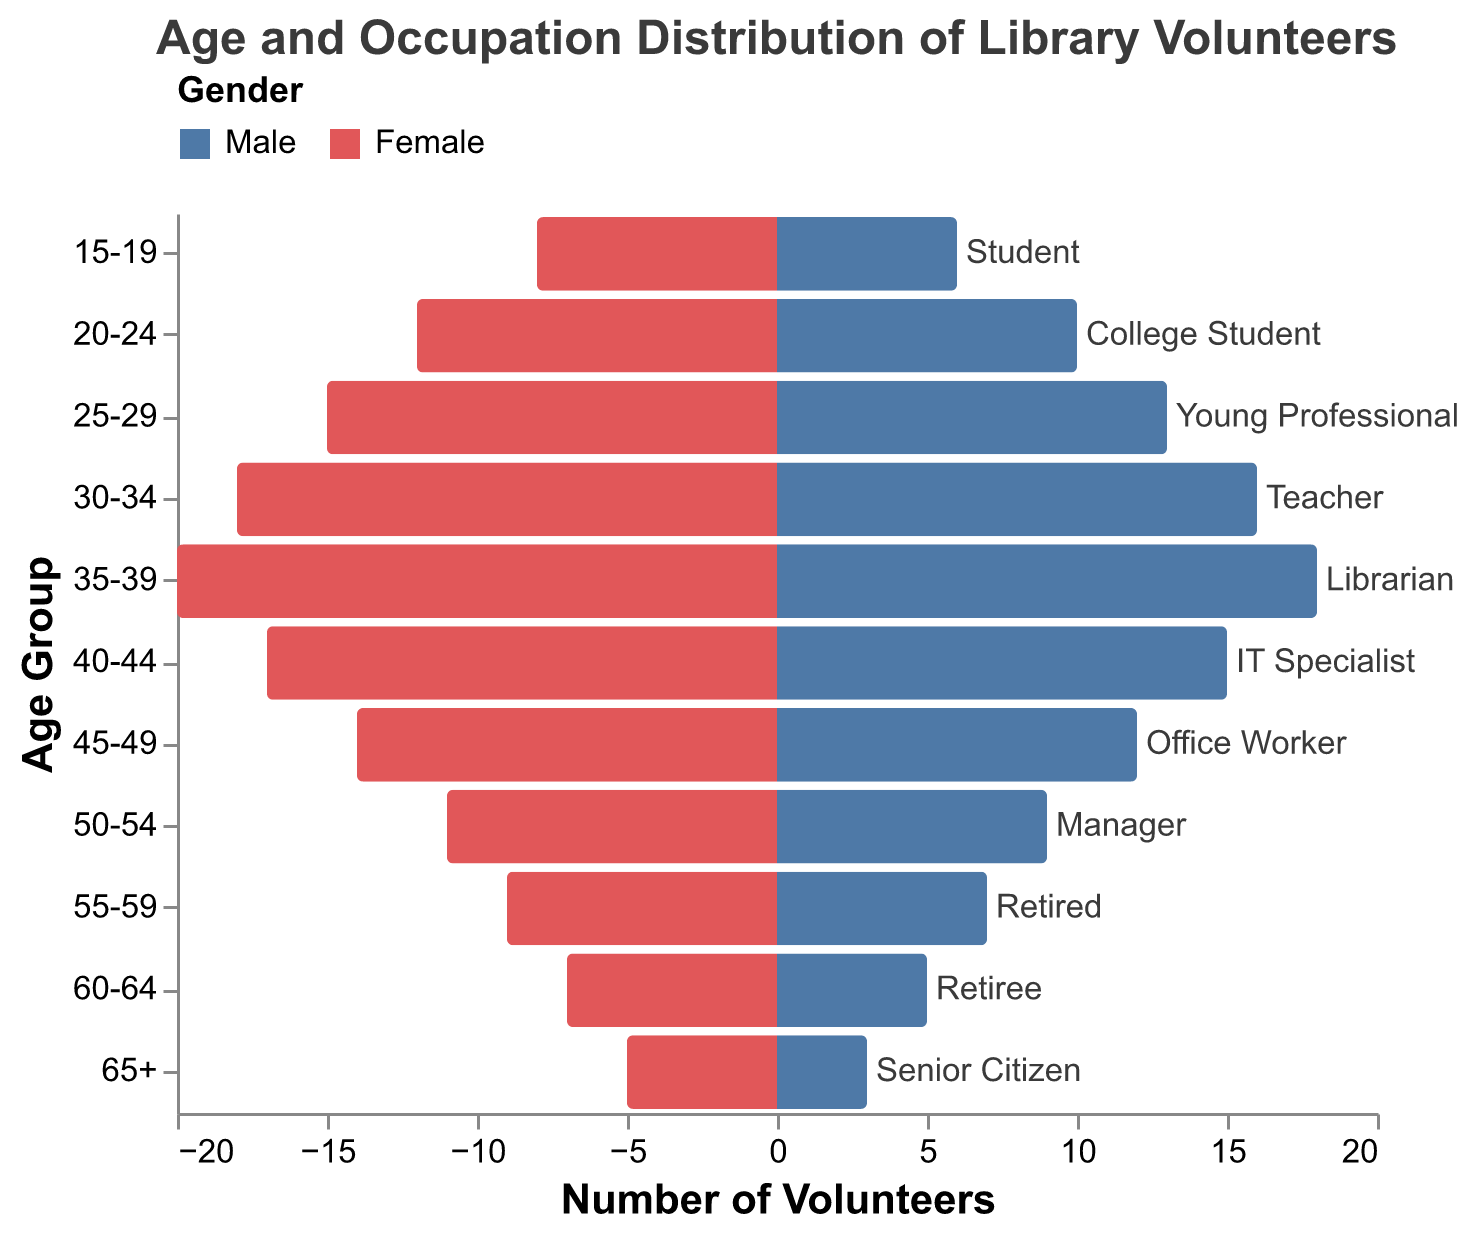What's the title of the plot? The title is located at the top of the plot and clearly states its purpose.
Answer: Age and Occupation Distribution of Library Volunteers What does the x-axis represent? The x-axis, which runs horizontally, represents the number of volunteers. This is denoted by the values extending left for females (negative) and right for males (positive).
Answer: Number of Volunteers Which age group has the highest number of female volunteers? We look at the bar that extends the furthest to the left on the female side. This corresponds to the age group 35-39 with 20 female volunteers.
Answer: 35-39 What is the typical occupation for volunteers aged 25-29? By finding the age group 25-29, we can see the annotation within or near the bar representing this group. The typical occupation for 25-29 is "Young Professional".
Answer: Young Professional How many male volunteers are there in the 30-34 age group? For the age group 30-34, we look at the length of the bar on the right side labeled as male, which corresponds to 16 male volunteers.
Answer: 16 Compare the number of volunteers for the age group 40-44. How many more females than males are there? For the age group 40-44, there are 17 females and 15 males. The difference is calculated as 17 - 15.
Answer: 2 Which gender has a higher number of volunteers in the age group 50-54? By comparing the lengths of the bars for the age group 50-54, we observe that more females (11) volunteer than males (9).
Answer: Female What is the sum of male volunteers in the age groups 60-64 and 65+? For age groups 60-64 and 65+, we add the number of male volunteers: 5 (60-64) + 3 (65+).
Answer: 8 Which age group has the smallest total number of volunteers? To find the smallest total, we sum male and female volunteers for each group and identify the smallest sum, which is for the age group 65+ (5 females + 3 males = 8).
Answer: 65+ What is the predominant occupation for volunteers aged 35-39? By examining the text annotations for the age group 35-39, we identify the predominant occupation as "Librarian".
Answer: Librarian 